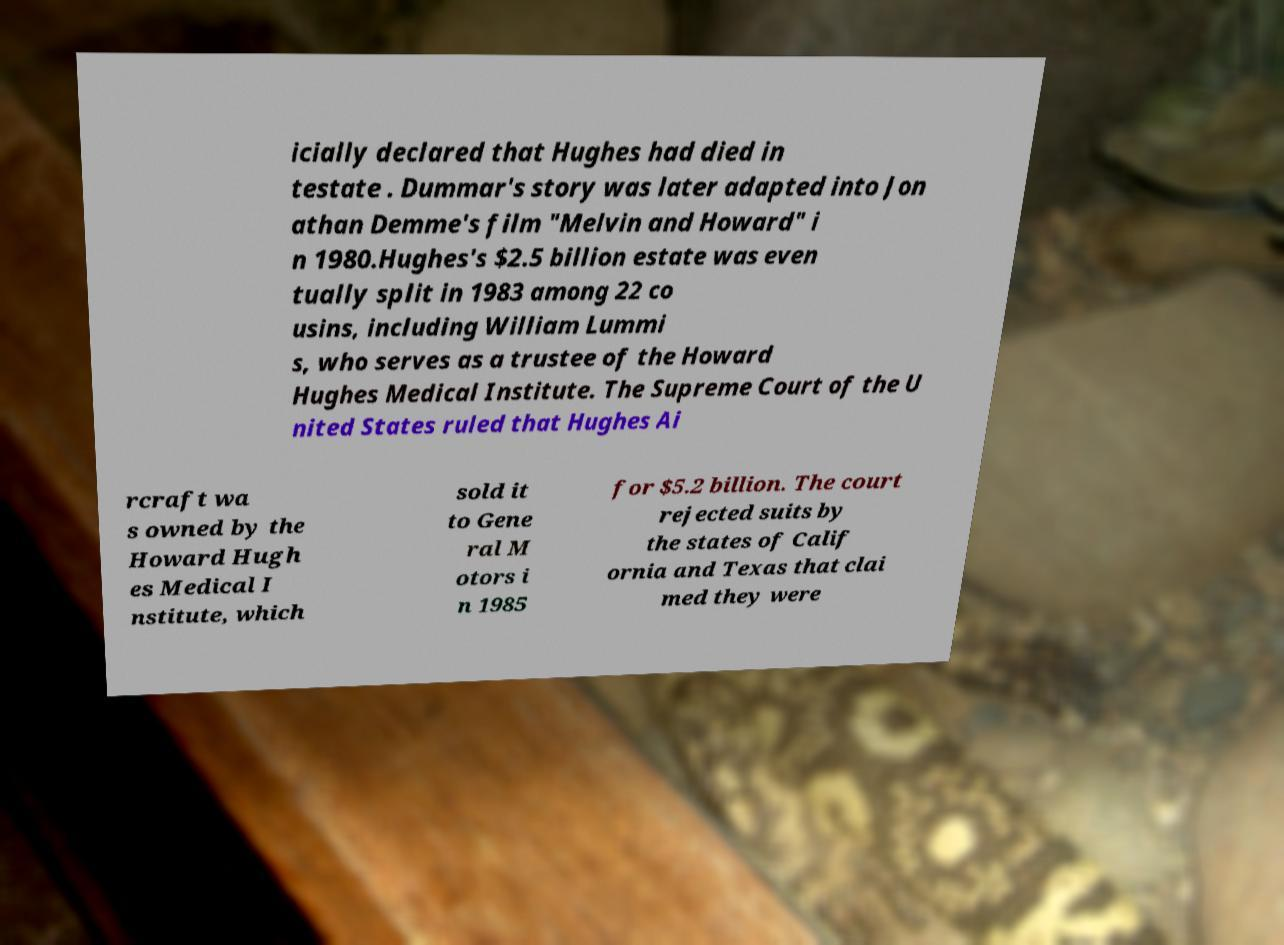Can you read and provide the text displayed in the image?This photo seems to have some interesting text. Can you extract and type it out for me? icially declared that Hughes had died in testate . Dummar's story was later adapted into Jon athan Demme's film "Melvin and Howard" i n 1980.Hughes's $2.5 billion estate was even tually split in 1983 among 22 co usins, including William Lummi s, who serves as a trustee of the Howard Hughes Medical Institute. The Supreme Court of the U nited States ruled that Hughes Ai rcraft wa s owned by the Howard Hugh es Medical I nstitute, which sold it to Gene ral M otors i n 1985 for $5.2 billion. The court rejected suits by the states of Calif ornia and Texas that clai med they were 